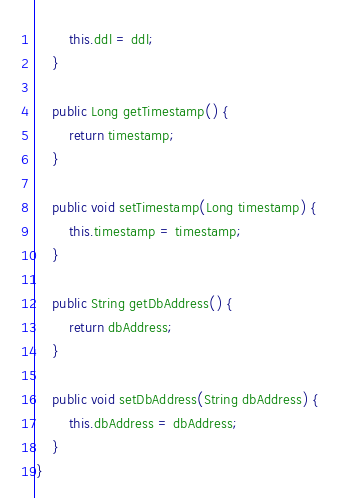Convert code to text. <code><loc_0><loc_0><loc_500><loc_500><_Java_>        this.ddl = ddl;
    }

    public Long getTimestamp() {
        return timestamp;
    }

    public void setTimestamp(Long timestamp) {
        this.timestamp = timestamp;
    }

    public String getDbAddress() {
        return dbAddress;
    }

    public void setDbAddress(String dbAddress) {
        this.dbAddress = dbAddress;
    }
}
</code> 